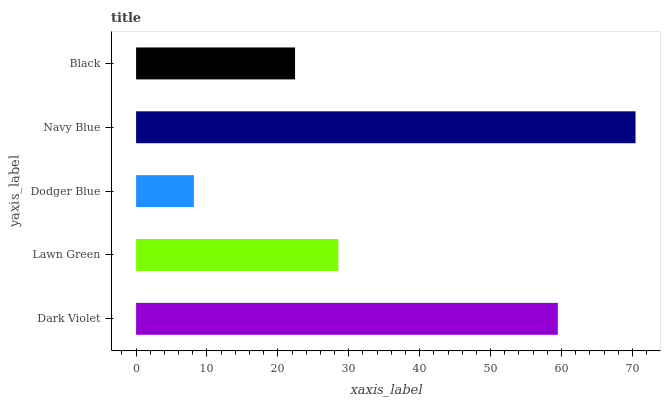Is Dodger Blue the minimum?
Answer yes or no. Yes. Is Navy Blue the maximum?
Answer yes or no. Yes. Is Lawn Green the minimum?
Answer yes or no. No. Is Lawn Green the maximum?
Answer yes or no. No. Is Dark Violet greater than Lawn Green?
Answer yes or no. Yes. Is Lawn Green less than Dark Violet?
Answer yes or no. Yes. Is Lawn Green greater than Dark Violet?
Answer yes or no. No. Is Dark Violet less than Lawn Green?
Answer yes or no. No. Is Lawn Green the high median?
Answer yes or no. Yes. Is Lawn Green the low median?
Answer yes or no. Yes. Is Dark Violet the high median?
Answer yes or no. No. Is Navy Blue the low median?
Answer yes or no. No. 